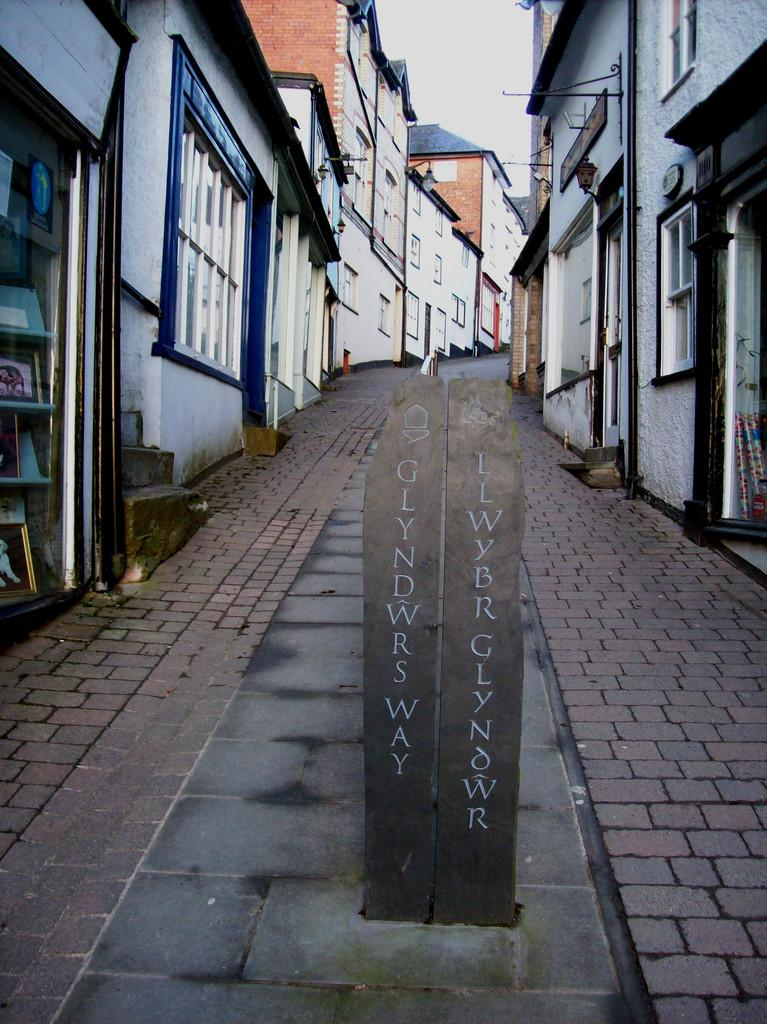What type of structure is visible in the image? There is a rectangular cement structure in the image. What can be seen on the structure? The structure has some text written on it. What is located behind the structure? There is a road behind the structure. What is visible on both sides of the road? Buildings are present on both sides of the road. How many dolls are sitting on the cement structure in the image? There are no dolls present in the image. 